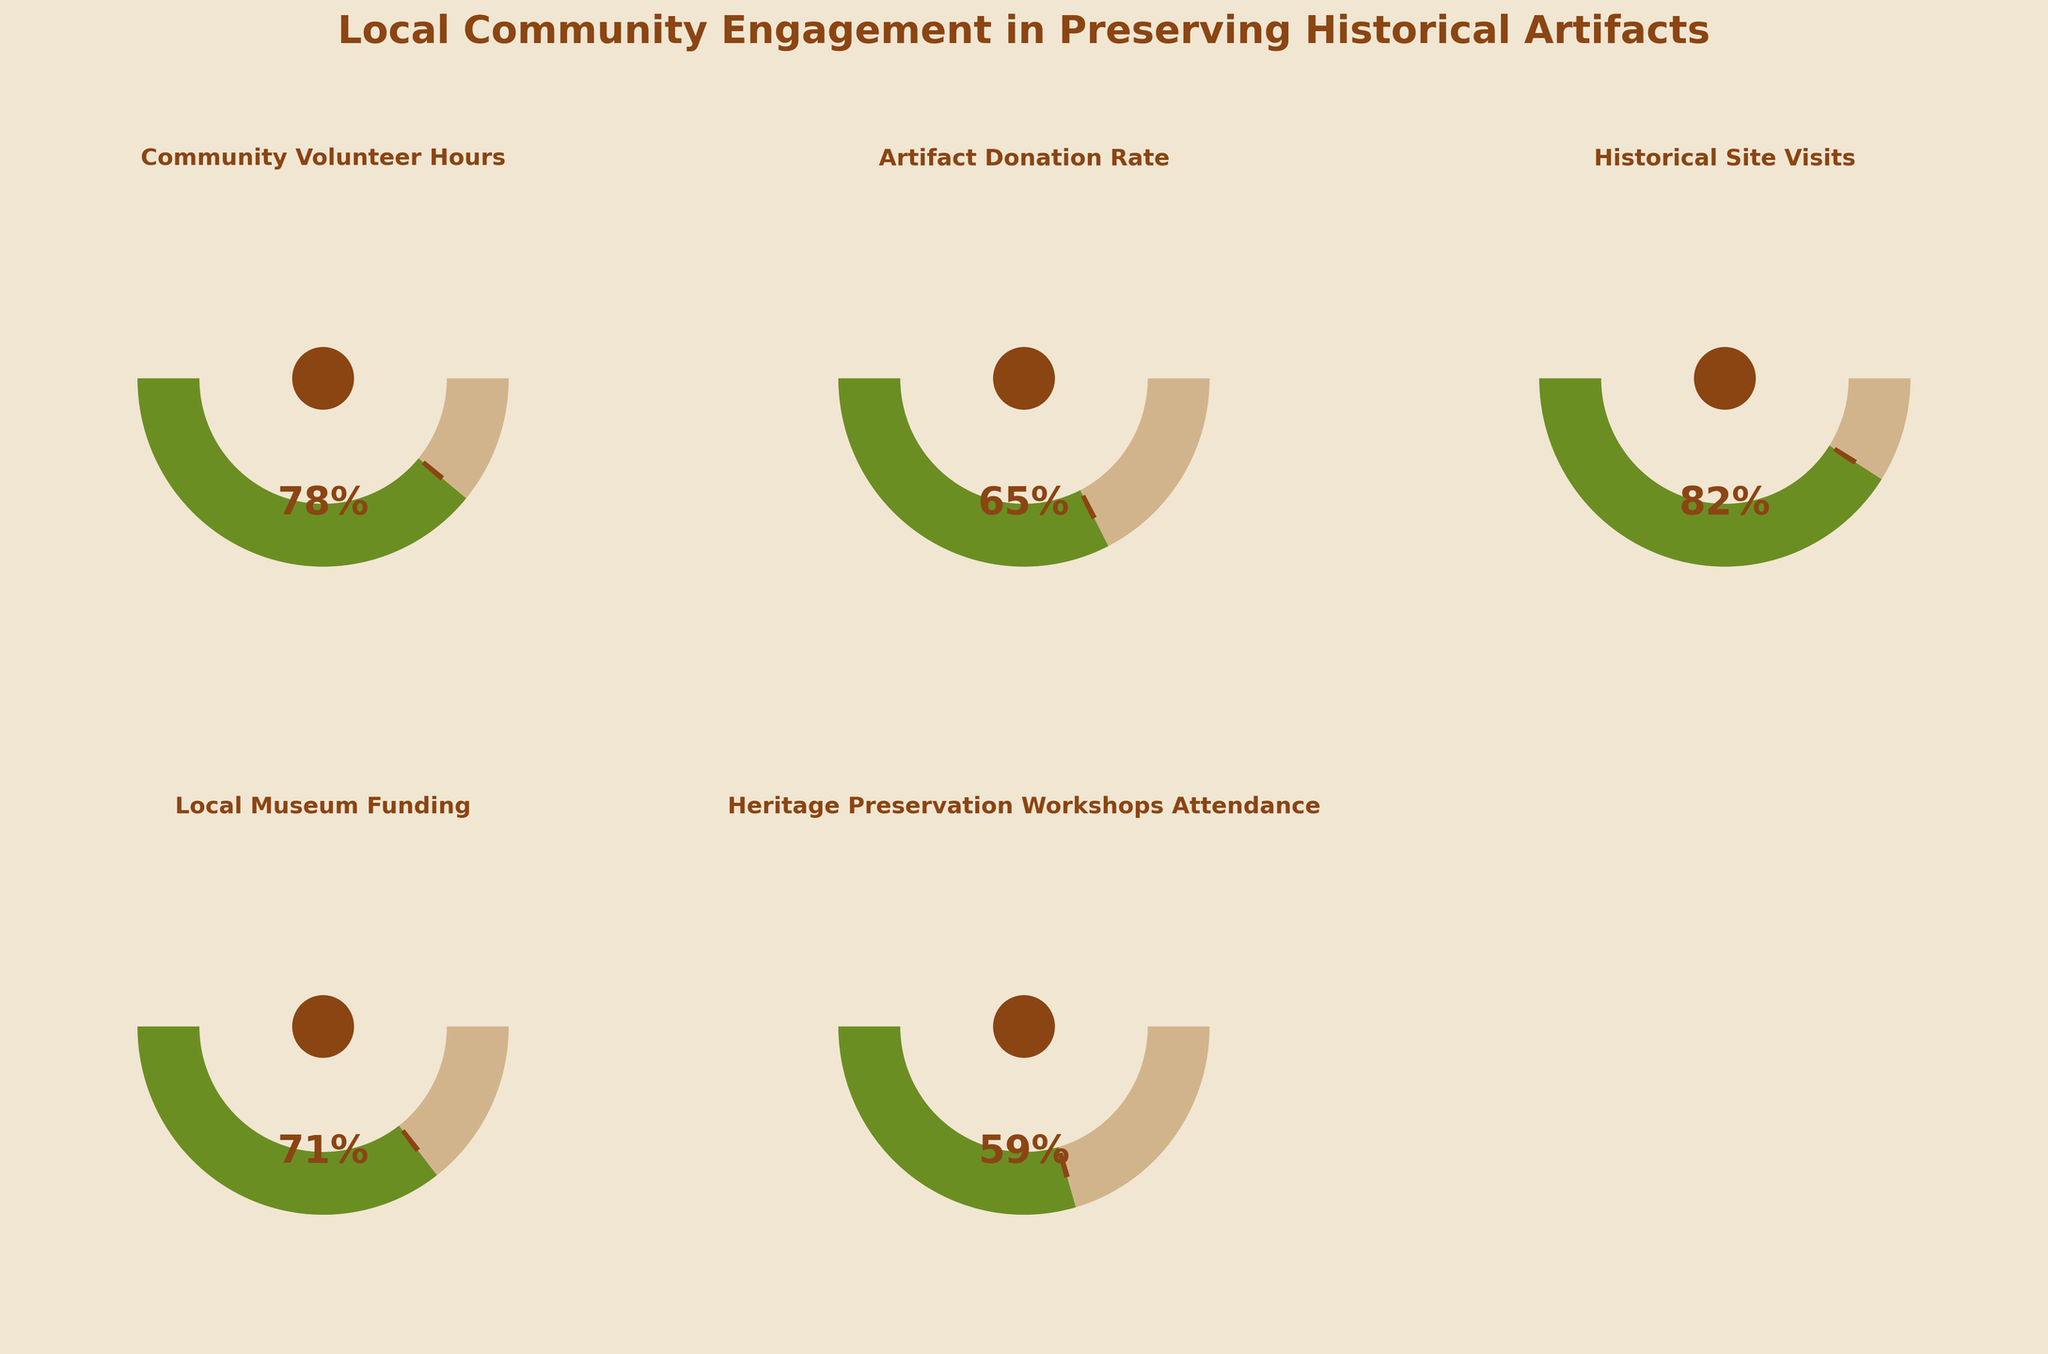what is the title of the plot? The title of the plot is located at the top of the figure. The title reads "Local Community Engagement in Preserving Historical Artifacts".
Answer: Local Community Engagement in Preserving Historical Artifacts what is the value for historical site visits? The value for historical site visits is displayed inside the gauge labeled "Historical Site Visits". This value is 82%.
Answer: 82% Which category has the lowest engagement value? To determine the lowest engagement value, examine all the gauges and compare their values. The "Heritage Preservation Workshops Attendance" has the lowest value, which is 59%.
Answer: Heritage Preservation Workshops Attendance what's the difference between the community volunteer hours and artifact donation rate values? To find the difference between the community volunteer hours (78%) and artifact donation rate (65%), subtract the smaller value from the larger value: 78 - 65 = 13.
Answer: 13 Which category has the highest engagement? To find the highest engagement category, compare all the gauge values. The "Historical Site Visits" has the highest engagement value at 82%.
Answer: Historical Site Visits what is the average value of all categories? To calculate the average value, sum up all the engagement values and divide by the number of categories. The values are 78, 65, 82, 71, and 59. The sum is 355, and the average is 355 / 5 = 71.
Answer: 71 Are there any categories with values over 80%? By inspecting the gauge values, "Historical Site Visits" is the only category with a value over 80%, which is 82%.
Answer: Yes How much higher is the local museum funding value compared to heritage preservation workshops attendance? The local museum funding value is 71% and the heritage preservation workshops attendance value is 59%. By subtracting the smaller value from the larger: 71 - 59 = 12.
Answer: 12 How many categories have values between 60% and 80%? To determine this, check each gauge value to see if it falls within the specified range: "Artifact Donation Rate" (65%) and "Local Museum Funding" (71%) fall in this range.
Answer: 2 Is the value for the community volunteer hours closer to the minimum or maximum range? The community volunteer hours value is 78%. Since the minimum range is 0 and the maximum range is 100, the distance to the minimum is 78 while the distance to the maximum is 22. Thus, it is closer to the maximum range.
Answer: Maximum range 